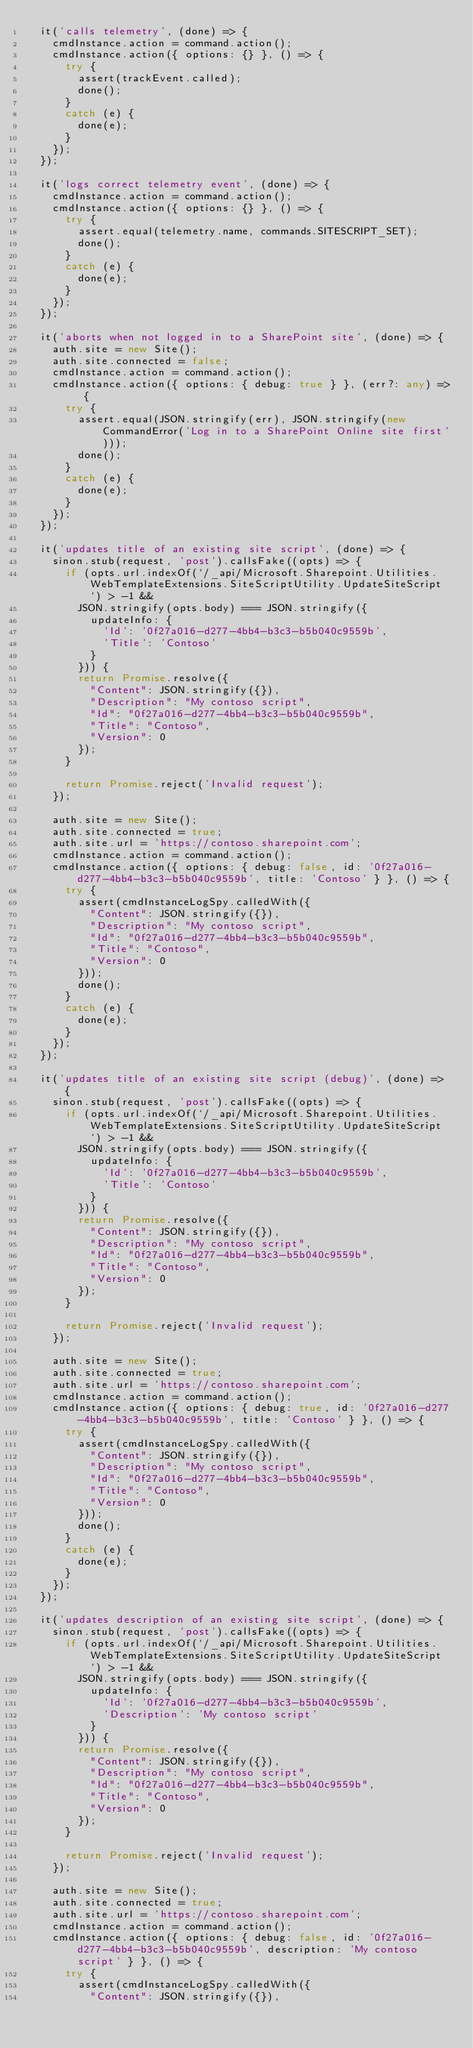<code> <loc_0><loc_0><loc_500><loc_500><_TypeScript_>  it('calls telemetry', (done) => {
    cmdInstance.action = command.action();
    cmdInstance.action({ options: {} }, () => {
      try {
        assert(trackEvent.called);
        done();
      }
      catch (e) {
        done(e);
      }
    });
  });

  it('logs correct telemetry event', (done) => {
    cmdInstance.action = command.action();
    cmdInstance.action({ options: {} }, () => {
      try {
        assert.equal(telemetry.name, commands.SITESCRIPT_SET);
        done();
      }
      catch (e) {
        done(e);
      }
    });
  });

  it('aborts when not logged in to a SharePoint site', (done) => {
    auth.site = new Site();
    auth.site.connected = false;
    cmdInstance.action = command.action();
    cmdInstance.action({ options: { debug: true } }, (err?: any) => {
      try {
        assert.equal(JSON.stringify(err), JSON.stringify(new CommandError('Log in to a SharePoint Online site first')));
        done();
      }
      catch (e) {
        done(e);
      }
    });
  });

  it('updates title of an existing site script', (done) => {
    sinon.stub(request, 'post').callsFake((opts) => {
      if (opts.url.indexOf(`/_api/Microsoft.Sharepoint.Utilities.WebTemplateExtensions.SiteScriptUtility.UpdateSiteScript`) > -1 &&
        JSON.stringify(opts.body) === JSON.stringify({
          updateInfo: {
            'Id': '0f27a016-d277-4bb4-b3c3-b5b040c9559b',
            'Title': 'Contoso'
          }
        })) {
        return Promise.resolve({
          "Content": JSON.stringify({}),
          "Description": "My contoso script",
          "Id": "0f27a016-d277-4bb4-b3c3-b5b040c9559b",
          "Title": "Contoso",
          "Version": 0
        });
      }

      return Promise.reject('Invalid request');
    });

    auth.site = new Site();
    auth.site.connected = true;
    auth.site.url = 'https://contoso.sharepoint.com';
    cmdInstance.action = command.action();
    cmdInstance.action({ options: { debug: false, id: '0f27a016-d277-4bb4-b3c3-b5b040c9559b', title: 'Contoso' } }, () => {
      try {
        assert(cmdInstanceLogSpy.calledWith({
          "Content": JSON.stringify({}),
          "Description": "My contoso script",
          "Id": "0f27a016-d277-4bb4-b3c3-b5b040c9559b",
          "Title": "Contoso",
          "Version": 0
        }));
        done();
      }
      catch (e) {
        done(e);
      }
    });
  });

  it('updates title of an existing site script (debug)', (done) => {
    sinon.stub(request, 'post').callsFake((opts) => {
      if (opts.url.indexOf(`/_api/Microsoft.Sharepoint.Utilities.WebTemplateExtensions.SiteScriptUtility.UpdateSiteScript`) > -1 &&
        JSON.stringify(opts.body) === JSON.stringify({
          updateInfo: {
            'Id': '0f27a016-d277-4bb4-b3c3-b5b040c9559b',
            'Title': 'Contoso'
          }
        })) {
        return Promise.resolve({
          "Content": JSON.stringify({}),
          "Description": "My contoso script",
          "Id": "0f27a016-d277-4bb4-b3c3-b5b040c9559b",
          "Title": "Contoso",
          "Version": 0
        });
      }

      return Promise.reject('Invalid request');
    });

    auth.site = new Site();
    auth.site.connected = true;
    auth.site.url = 'https://contoso.sharepoint.com';
    cmdInstance.action = command.action();
    cmdInstance.action({ options: { debug: true, id: '0f27a016-d277-4bb4-b3c3-b5b040c9559b', title: 'Contoso' } }, () => {
      try {
        assert(cmdInstanceLogSpy.calledWith({
          "Content": JSON.stringify({}),
          "Description": "My contoso script",
          "Id": "0f27a016-d277-4bb4-b3c3-b5b040c9559b",
          "Title": "Contoso",
          "Version": 0
        }));
        done();
      }
      catch (e) {
        done(e);
      }
    });
  });

  it('updates description of an existing site script', (done) => {
    sinon.stub(request, 'post').callsFake((opts) => {
      if (opts.url.indexOf(`/_api/Microsoft.Sharepoint.Utilities.WebTemplateExtensions.SiteScriptUtility.UpdateSiteScript`) > -1 &&
        JSON.stringify(opts.body) === JSON.stringify({
          updateInfo: {
            'Id': '0f27a016-d277-4bb4-b3c3-b5b040c9559b',
            'Description': 'My contoso script'
          }
        })) {
        return Promise.resolve({
          "Content": JSON.stringify({}),
          "Description": "My contoso script",
          "Id": "0f27a016-d277-4bb4-b3c3-b5b040c9559b",
          "Title": "Contoso",
          "Version": 0
        });
      }

      return Promise.reject('Invalid request');
    });

    auth.site = new Site();
    auth.site.connected = true;
    auth.site.url = 'https://contoso.sharepoint.com';
    cmdInstance.action = command.action();
    cmdInstance.action({ options: { debug: false, id: '0f27a016-d277-4bb4-b3c3-b5b040c9559b', description: 'My contoso script' } }, () => {
      try {
        assert(cmdInstanceLogSpy.calledWith({
          "Content": JSON.stringify({}),</code> 